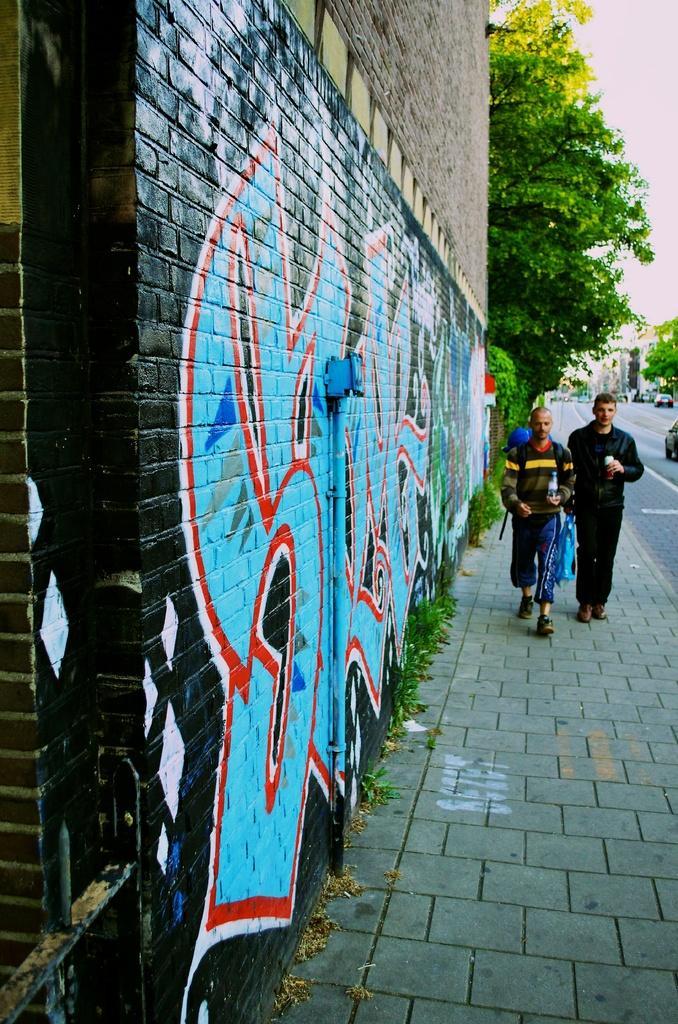Could you give a brief overview of what you see in this image? The picture is taken on the streets of a city. On the left there is a wall with graffiti. In the center of the picture it is footpath, on the footpath there are people and plants. In the background there are trees, buildings and vehicles, on the road. Sky is cloudy. 